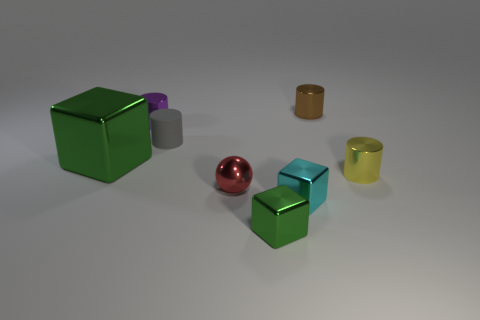Is the material of the large green thing the same as the green object in front of the large green thing? Yes, both the large green cube and the smaller green object in front of it appear to be made of the same reflective material, exhibiting similar light-reflecting properties and sheen. 